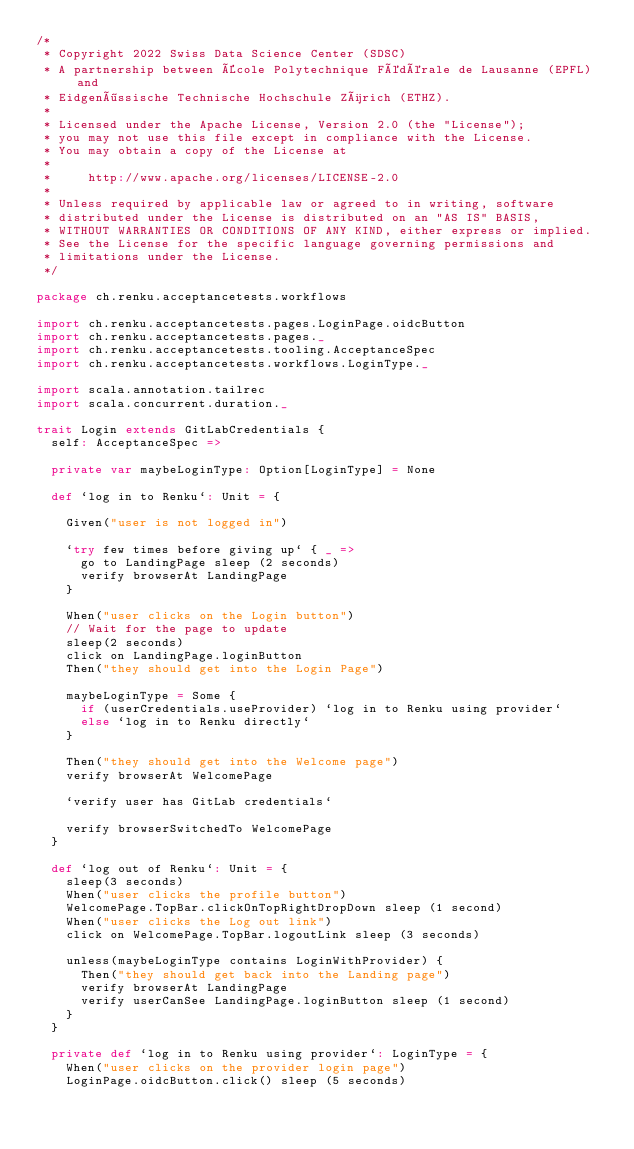<code> <loc_0><loc_0><loc_500><loc_500><_Scala_>/*
 * Copyright 2022 Swiss Data Science Center (SDSC)
 * A partnership between École Polytechnique Fédérale de Lausanne (EPFL) and
 * Eidgenössische Technische Hochschule Zürich (ETHZ).
 *
 * Licensed under the Apache License, Version 2.0 (the "License");
 * you may not use this file except in compliance with the License.
 * You may obtain a copy of the License at
 *
 *     http://www.apache.org/licenses/LICENSE-2.0
 *
 * Unless required by applicable law or agreed to in writing, software
 * distributed under the License is distributed on an "AS IS" BASIS,
 * WITHOUT WARRANTIES OR CONDITIONS OF ANY KIND, either express or implied.
 * See the License for the specific language governing permissions and
 * limitations under the License.
 */

package ch.renku.acceptancetests.workflows

import ch.renku.acceptancetests.pages.LoginPage.oidcButton
import ch.renku.acceptancetests.pages._
import ch.renku.acceptancetests.tooling.AcceptanceSpec
import ch.renku.acceptancetests.workflows.LoginType._

import scala.annotation.tailrec
import scala.concurrent.duration._

trait Login extends GitLabCredentials {
  self: AcceptanceSpec =>

  private var maybeLoginType: Option[LoginType] = None

  def `log in to Renku`: Unit = {

    Given("user is not logged in")

    `try few times before giving up` { _ =>
      go to LandingPage sleep (2 seconds)
      verify browserAt LandingPage
    }

    When("user clicks on the Login button")
    // Wait for the page to update
    sleep(2 seconds)
    click on LandingPage.loginButton
    Then("they should get into the Login Page")

    maybeLoginType = Some {
      if (userCredentials.useProvider) `log in to Renku using provider`
      else `log in to Renku directly`
    }

    Then("they should get into the Welcome page")
    verify browserAt WelcomePage

    `verify user has GitLab credentials`

    verify browserSwitchedTo WelcomePage
  }

  def `log out of Renku`: Unit = {
    sleep(3 seconds)
    When("user clicks the profile button")
    WelcomePage.TopBar.clickOnTopRightDropDown sleep (1 second)
    When("user clicks the Log out link")
    click on WelcomePage.TopBar.logoutLink sleep (3 seconds)

    unless(maybeLoginType contains LoginWithProvider) {
      Then("they should get back into the Landing page")
      verify browserAt LandingPage
      verify userCanSee LandingPage.loginButton sleep (1 second)
    }
  }

  private def `log in to Renku using provider`: LoginType = {
    When("user clicks on the provider login page")
    LoginPage.oidcButton.click() sleep (5 seconds)
</code> 